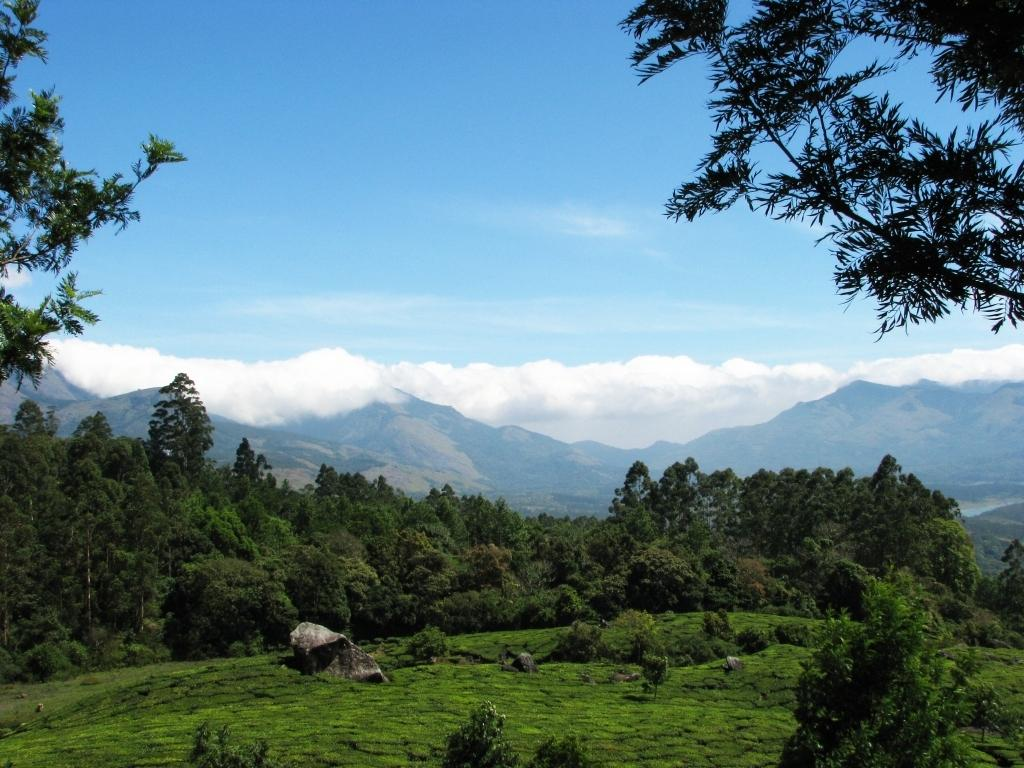What type of terrain is visible in the image? Ground, grass, and plants are visible in the image. Can you describe any specific features in the image? There is a rock and trees in the image. What is visible in the background of the image? There is a mountain and sky visible in the background of the image. What can be seen in the sky? Clouds can be seen in the sky. What type of juice is being squeezed out of the patch in the image? There is no juice or patch present in the image. What scent can be detected from the image? The image does not convey any scents, as it is a visual representation. 